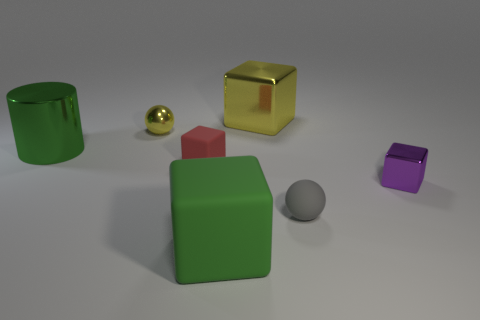Besides color and material, what other properties vary among the objects? The objects vary in size, shape, and position. There are cubes, spheres, and a cylinder, ranging from small to large, and they are placed at varying distances from one another. 